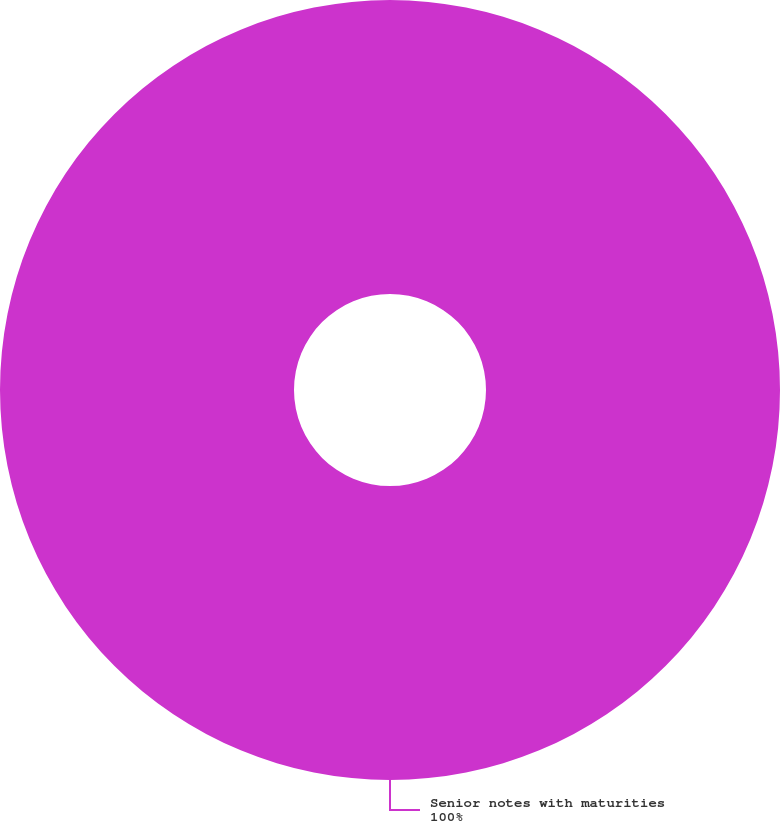Convert chart. <chart><loc_0><loc_0><loc_500><loc_500><pie_chart><fcel>Senior notes with maturities<nl><fcel>100.0%<nl></chart> 